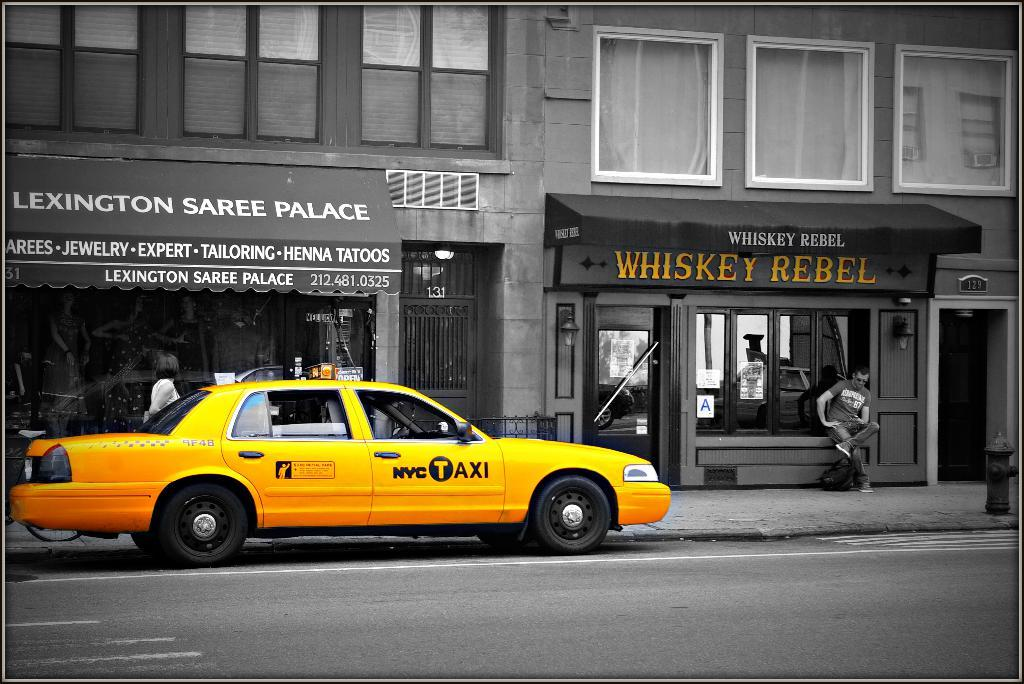<image>
Summarize the visual content of the image. A yellow taxi cab parked on the side of a street in from to of a Lexington Saree Palace building ans a Whiskey Rebel building. 